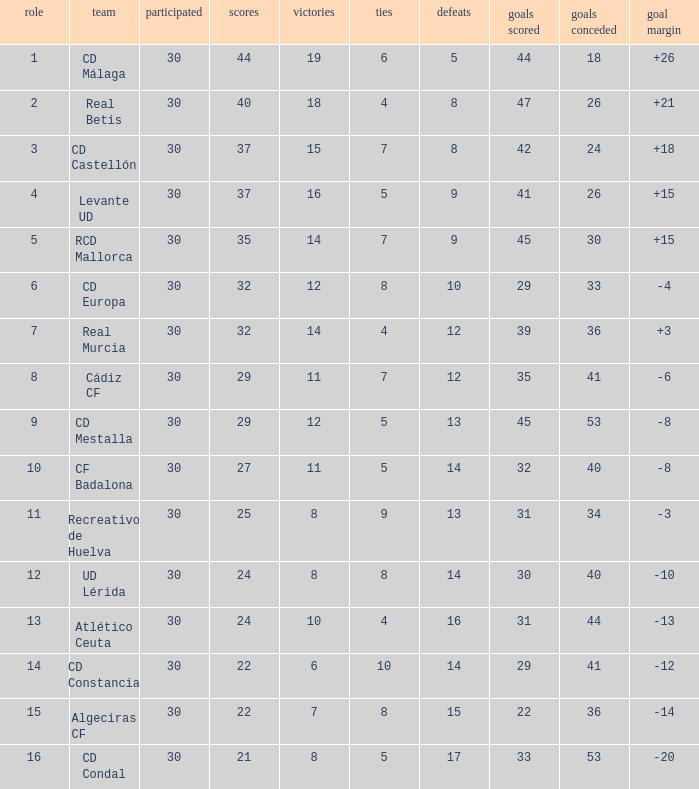What is the losses when the goal difference is larger than 26? None. 